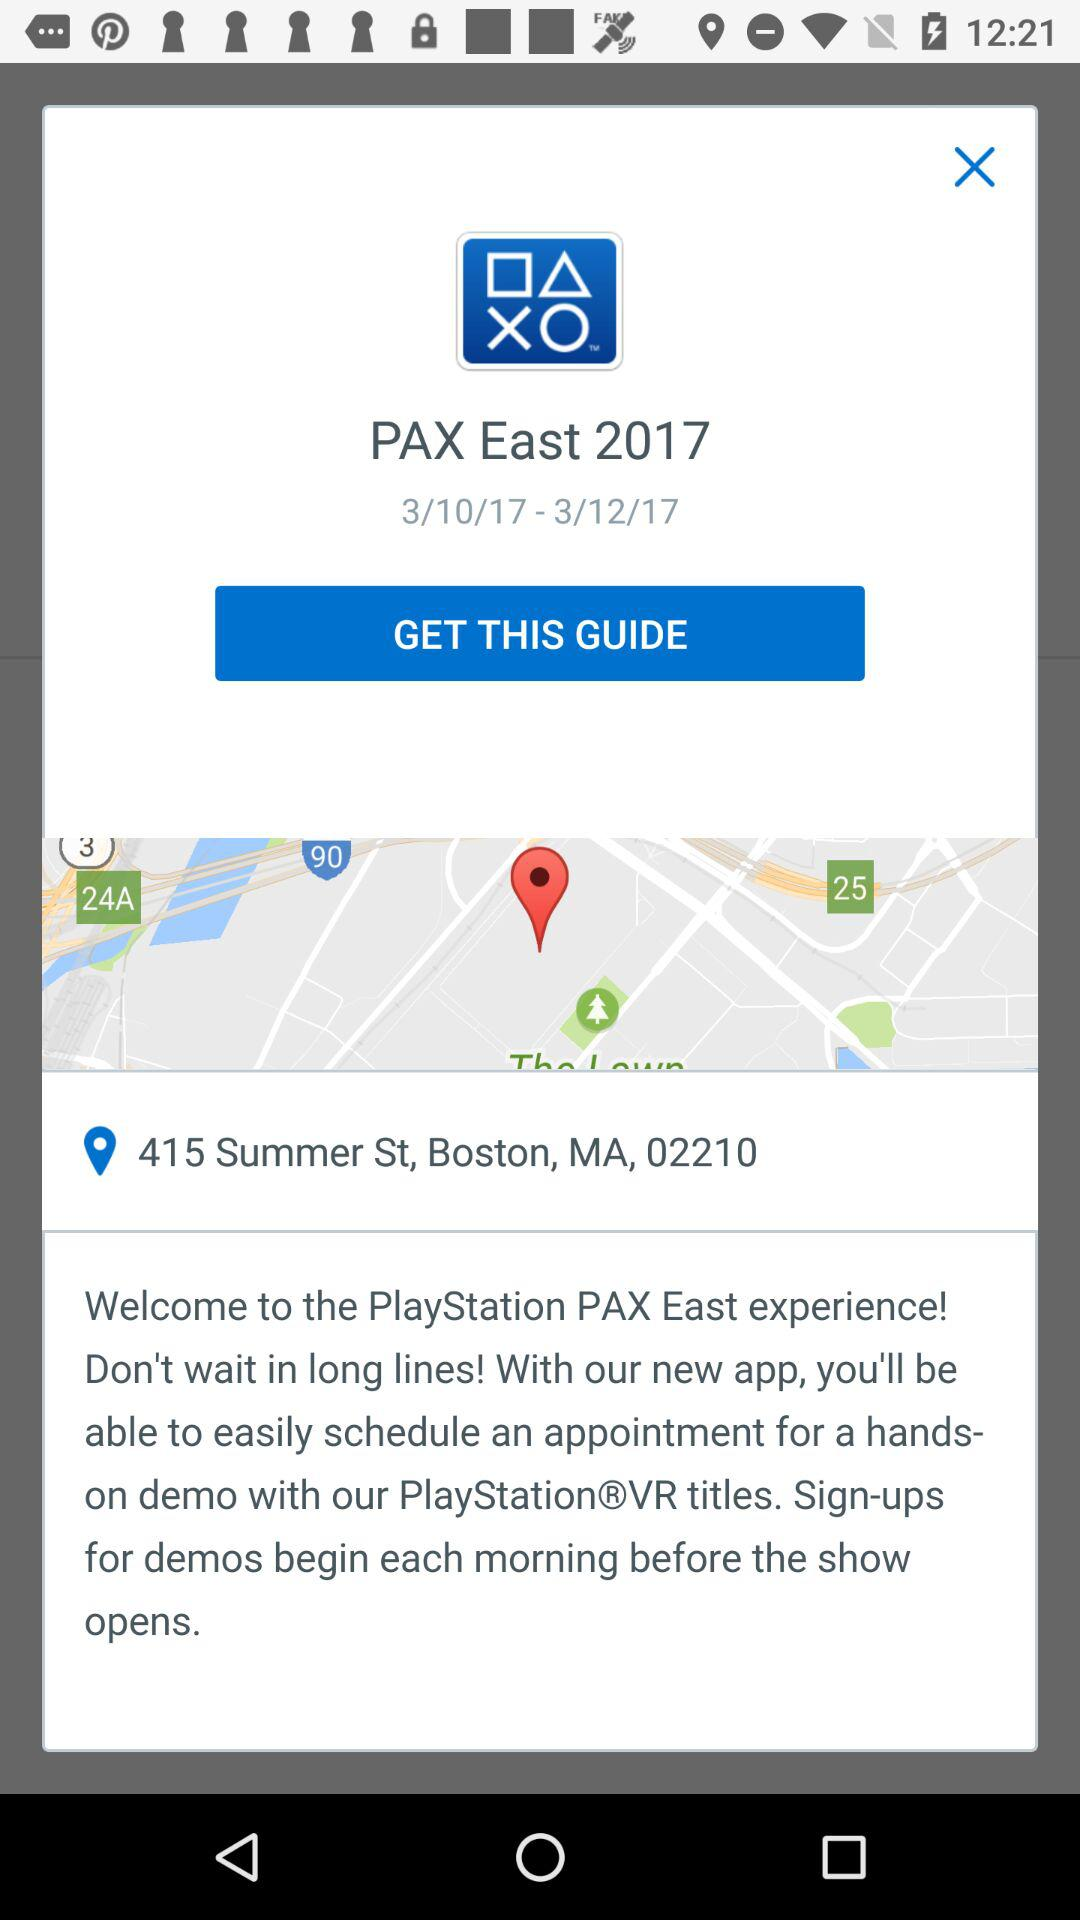What is the name of the application? The name of the application is "PlayStation". 